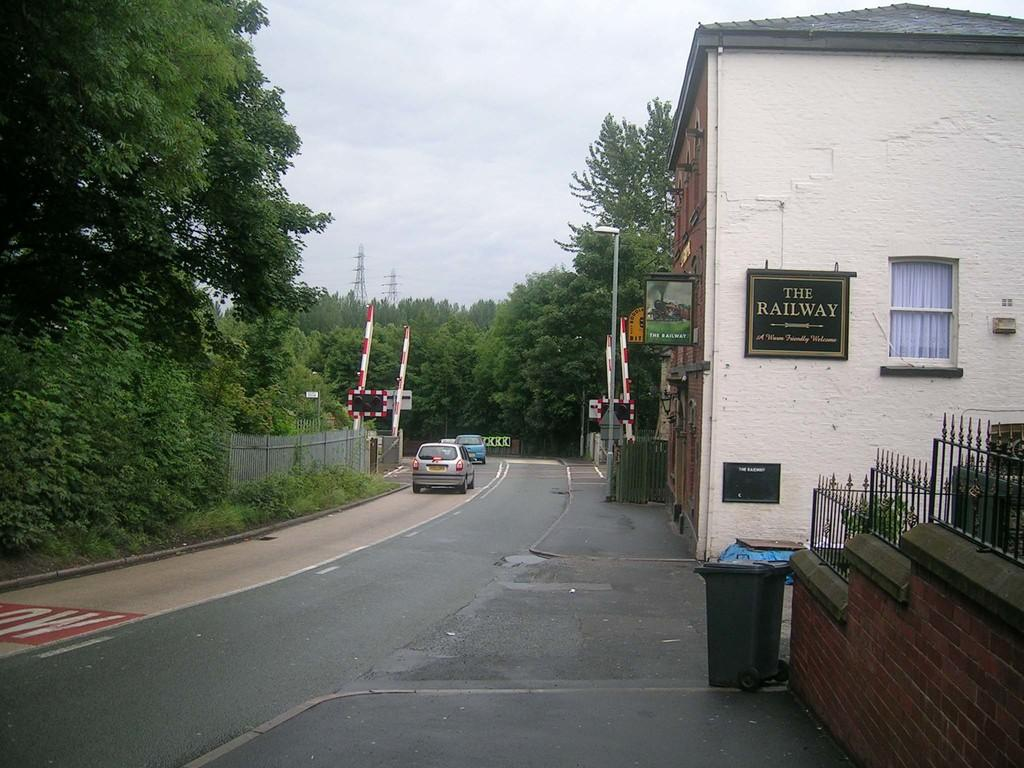<image>
Describe the image concisely. Cars are driving over railroad tracks just past a building with a sign on it that says it is The Railway House. 